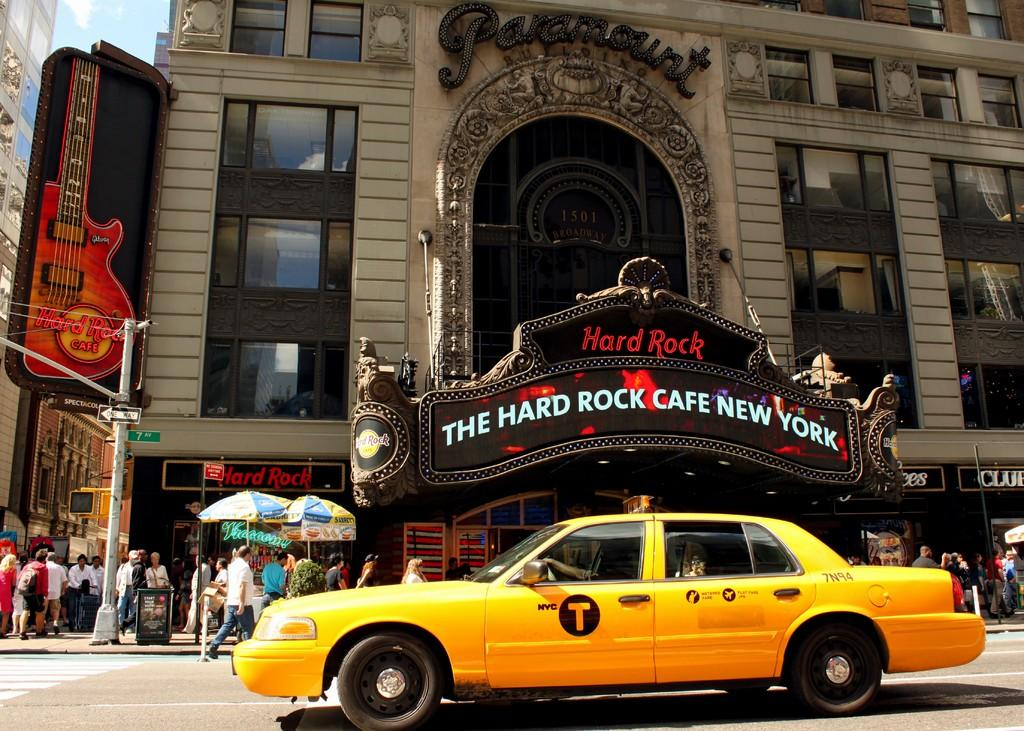<image>
Give a short and clear explanation of the subsequent image. The Hard Rock Cafe New York Building with a Taxi Cab in front that says 7N94. 